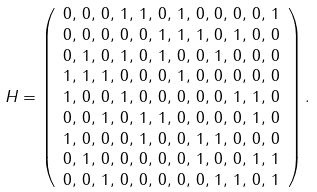Convert formula to latex. <formula><loc_0><loc_0><loc_500><loc_500>H & = \left ( \begin{array} { c } 0 , \, 0 , \, 0 , \, 1 , \, 1 , \, 0 , \, 1 , \, 0 , \, 0 , \, 0 , \, 0 , \, 1 \\ 0 , \, 0 , \, 0 , \, 0 , \, 0 , \, 1 , \, 1 , \, 1 , \, 0 , \, 1 , \, 0 , \, 0 \\ 0 , \, 1 , \, 0 , \, 1 , \, 0 , \, 1 , \, 0 , \, 0 , \, 1 , \, 0 , \, 0 , \, 0 \\ 1 , \, 1 , \, 1 , \, 0 , \, 0 , \, 0 , \, 1 , \, 0 , \, 0 , \, 0 , \, 0 , \, 0 \\ 1 , \, 0 , \, 0 , \, 1 , \, 0 , \, 0 , \, 0 , \, 0 , \, 0 , \, 1 , \, 1 , \, 0 \\ 0 , \, 0 , \, 1 , \, 0 , \, 1 , \, 1 , \, 0 , \, 0 , \, 0 , \, 0 , \, 1 , \, 0 \\ 1 , \, 0 , \, 0 , \, 0 , \, 1 , \, 0 , \, 0 , \, 1 , \, 1 , \, 0 , \, 0 , \, 0 \\ 0 , \, 1 , \, 0 , \, 0 , \, 0 , \, 0 , \, 0 , \, 1 , \, 0 , \, 0 , \, 1 , \, 1 \\ 0 , \, 0 , \, 1 , \, 0 , \, 0 , \, 0 , \, 0 , \, 0 , \, 1 , \, 1 , \, 0 , \, 1 \end{array} \right ) .</formula> 